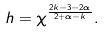Convert formula to latex. <formula><loc_0><loc_0><loc_500><loc_500>h = \chi ^ { \frac { 2 k - 3 - 2 \alpha } { 2 + \alpha - k } } .</formula> 